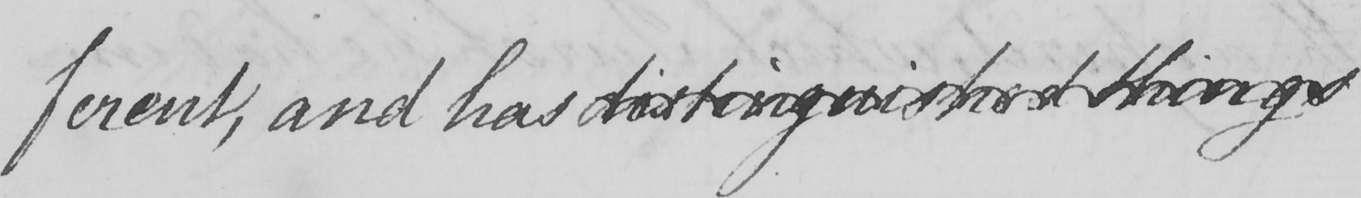What text is written in this handwritten line? ferent , and has distinguished things 